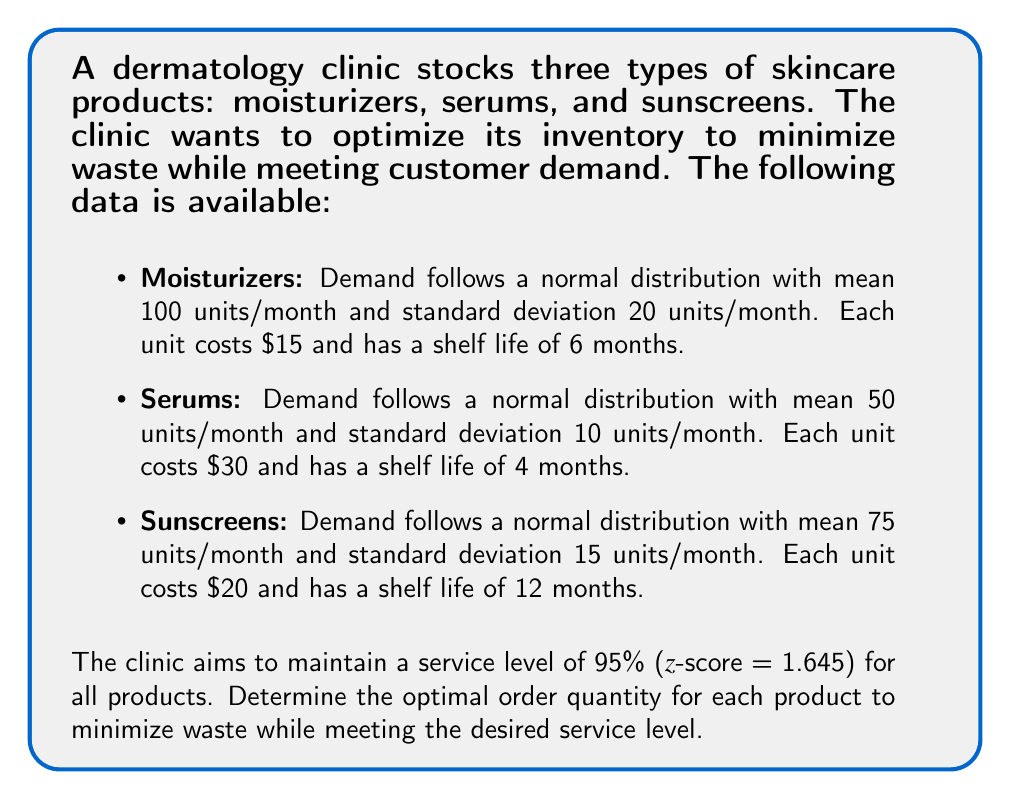Provide a solution to this math problem. To solve this problem, we'll use the Economic Order Quantity (EOQ) model with safety stock to account for demand variability and desired service level. The steps are as follows:

1. Calculate the safety stock for each product:
   Safety Stock = z-score × standard deviation × $\sqrt{\text{lead time}}$
   (Assuming a lead time of 1 month for all products)

2. Calculate the reorder point for each product:
   Reorder Point = (Average monthly demand × lead time) + Safety Stock

3. Calculate the EOQ for each product:
   $EOQ = \sqrt{\frac{2 \times \text{Annual Demand} \times \text{Ordering Cost}}{\text{Holding Cost}}}$

   Assuming an ordering cost of $50 per order and an annual holding cost of 20% of the product's value.

4. Adjust the EOQ to account for the product's shelf life:
   If EOQ > (Shelf life in months × Average monthly demand), then use:
   Adjusted EOQ = Shelf life in months × Average monthly demand

Let's calculate for each product:

Moisturizers:
1. Safety Stock = 1.645 × 20 × $\sqrt{1}$ = 32.9 units
2. Reorder Point = (100 × 1) + 32.9 = 132.9 units
3. $EOQ = \sqrt{\frac{2 \times (100 \times 12) \times 50}{0.2 \times 15}} = 316.2$ units
4. Adjusted EOQ = min(316.2, 6 × 100) = 316.2 units

Serums:
1. Safety Stock = 1.645 × 10 × $\sqrt{1}$ = 16.45 units
2. Reorder Point = (50 × 1) + 16.45 = 66.45 units
3. $EOQ = \sqrt{\frac{2 \times (50 \times 12) \times 50}{0.2 \times 30}} = 158.1$ units
4. Adjusted EOQ = min(158.1, 4 × 50) = 158.1 units

Sunscreens:
1. Safety Stock = 1.645 × 15 × $\sqrt{1}$ = 24.675 units
2. Reorder Point = (75 × 1) + 24.675 = 99.675 units
3. $EOQ = \sqrt{\frac{2 \times (75 \times 12) \times 50}{0.2 \times 20}} = 237.2$ units
4. Adjusted EOQ = min(237.2, 12 × 75) = 237.2 units

The optimal order quantity for each product is the Adjusted EOQ, rounded to the nearest whole number.
Answer: The optimal order quantities to minimize waste while meeting the 95% service level are:
- Moisturizers: 316 units
- Serums: 158 units
- Sunscreens: 237 units 